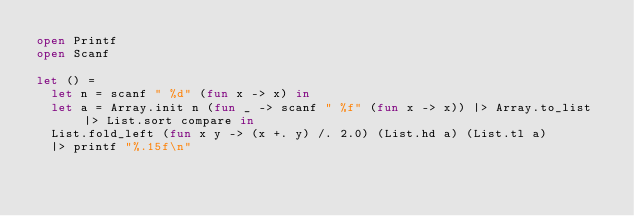<code> <loc_0><loc_0><loc_500><loc_500><_OCaml_>open Printf
open Scanf

let () =
  let n = scanf " %d" (fun x -> x) in
  let a = Array.init n (fun _ -> scanf " %f" (fun x -> x)) |> Array.to_list |> List.sort compare in
  List.fold_left (fun x y -> (x +. y) /. 2.0) (List.hd a) (List.tl a)
  |> printf "%.15f\n"</code> 